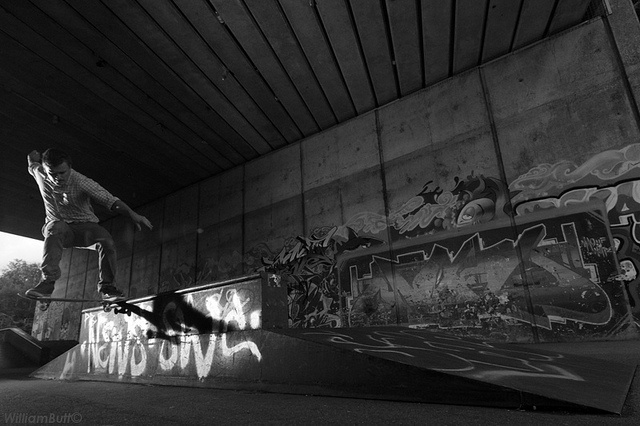Describe the objects in this image and their specific colors. I can see people in black, gray, darkgray, and lightgray tones and skateboard in black, gray, and lightgray tones in this image. 